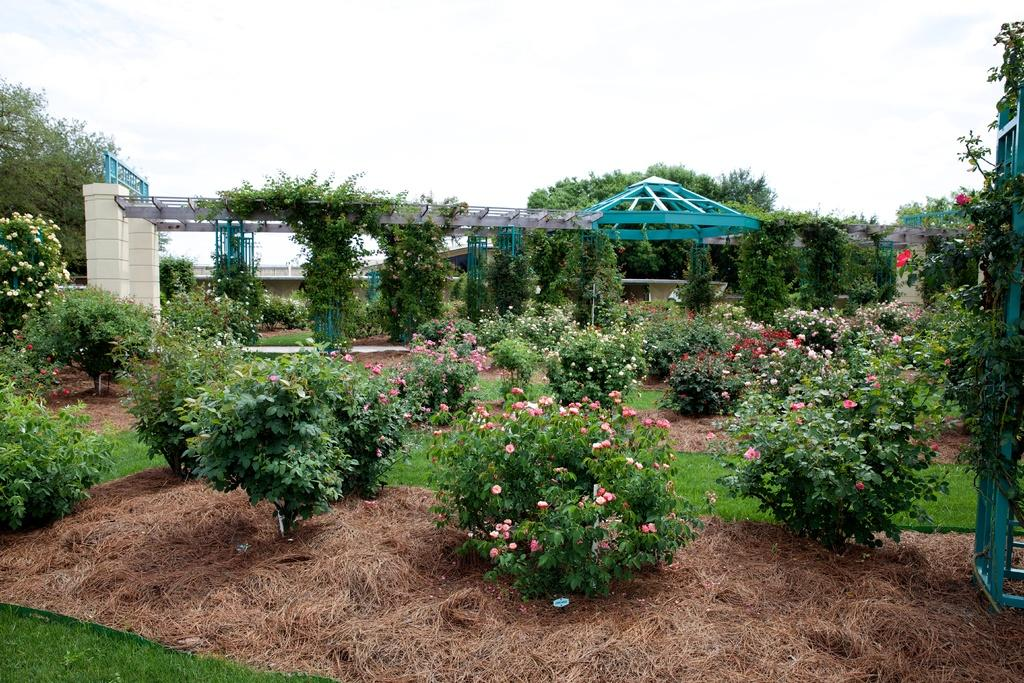What type of vegetation can be seen in the image? There are trees, plants, and grass in the image. Are there any climbing plants visible in the image? Yes, there are creepers in the image. What type of structure is present in the image? There is a building and an arch in the image. What can be seen in the background of the image? There are clouds and the sky visible in the background of the image. Can you tell me how many goats are grazing in the garden in the image? There is no garden or goats present in the image. What type of farmer is tending to the plants in the image? There is no farmer present in the image. 